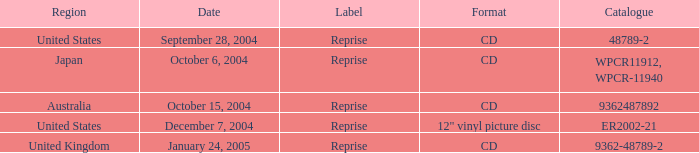What is the catalog called for australia? 9362487892.0. 